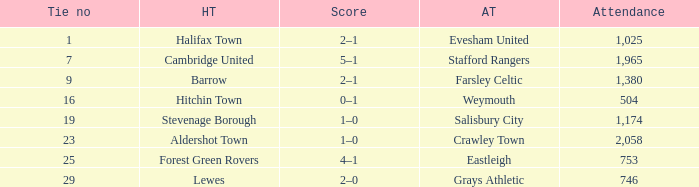How many attended tie number 19? 1174.0. 